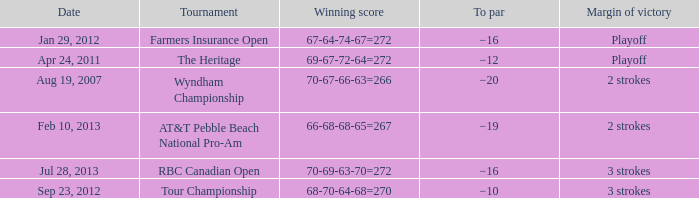What tournament was on Jan 29, 2012? Farmers Insurance Open. 